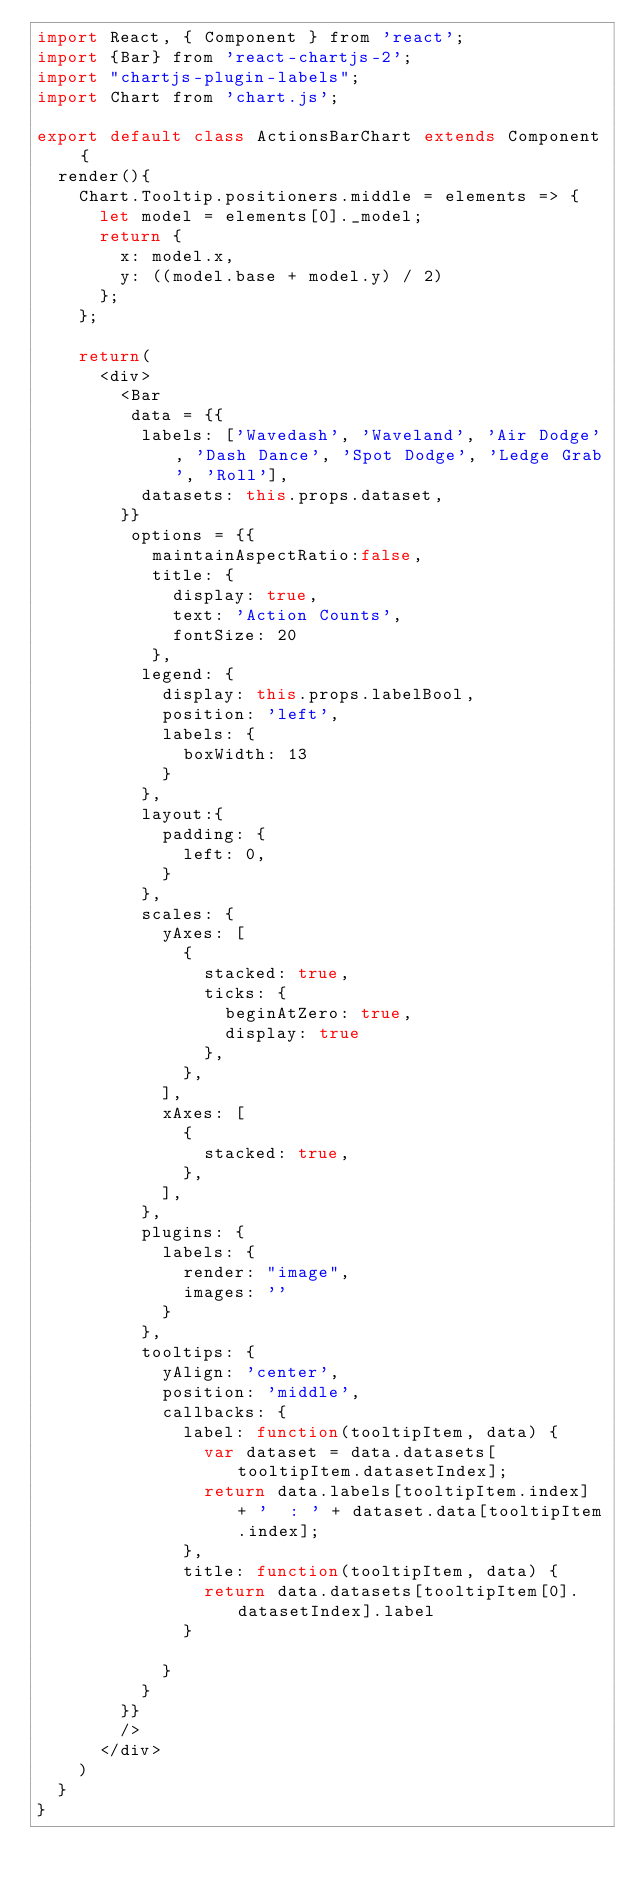Convert code to text. <code><loc_0><loc_0><loc_500><loc_500><_JavaScript_>import React, { Component } from 'react';
import {Bar} from 'react-chartjs-2';
import "chartjs-plugin-labels";
import Chart from 'chart.js';

export default class ActionsBarChart extends Component {
  render(){
    Chart.Tooltip.positioners.middle = elements => {
      let model = elements[0]._model;
      return {
        x: model.x,
        y: ((model.base + model.y) / 2)
      };
    };

    return(
      <div>
        <Bar
         data = {{
          labels: ['Wavedash', 'Waveland', 'Air Dodge', 'Dash Dance', 'Spot Dodge', 'Ledge Grab', 'Roll'],
          datasets: this.props.dataset,
        }}
         options = {{
           maintainAspectRatio:false,
           title: {
             display: true,
             text: 'Action Counts',
             fontSize: 20
           },
          legend: {
            display: this.props.labelBool,
            position: 'left',
            labels: {
              boxWidth: 13
            }
          },
          layout:{
            padding: {
              left: 0,
            }
          },
          scales: {
            yAxes: [
              {
                stacked: true,
                ticks: {
                  beginAtZero: true,
                  display: true
                },
              },
            ],
            xAxes: [
              {
                stacked: true,
              },
            ],
          },
          plugins: {
            labels: {
              render: "image",
              images: ''
            }
          },
          tooltips: {            
            yAlign: 'center',
            position: 'middle',
            callbacks: {
              label: function(tooltipItem, data) {
                var dataset = data.datasets[tooltipItem.datasetIndex];
                return data.labels[tooltipItem.index] + '  : ' + dataset.data[tooltipItem.index];
              },
              title: function(tooltipItem, data) {
                return data.datasets[tooltipItem[0].datasetIndex].label
              }
              
            }
          }
        }}
        />
      </div>
    )
  }
}</code> 